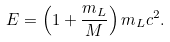<formula> <loc_0><loc_0><loc_500><loc_500>E = \left ( 1 + \frac { m _ { L } } { M } \right ) m _ { L } c ^ { 2 } .</formula> 